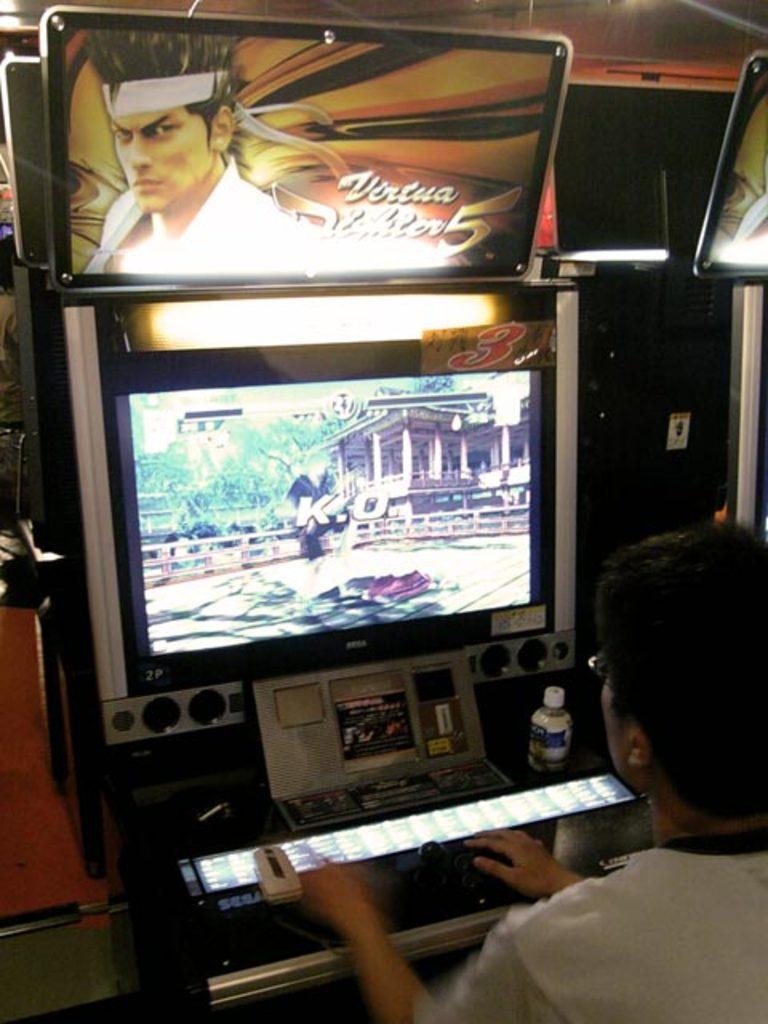What video game is this?
Your answer should be very brief. Virtua fighter 5. 